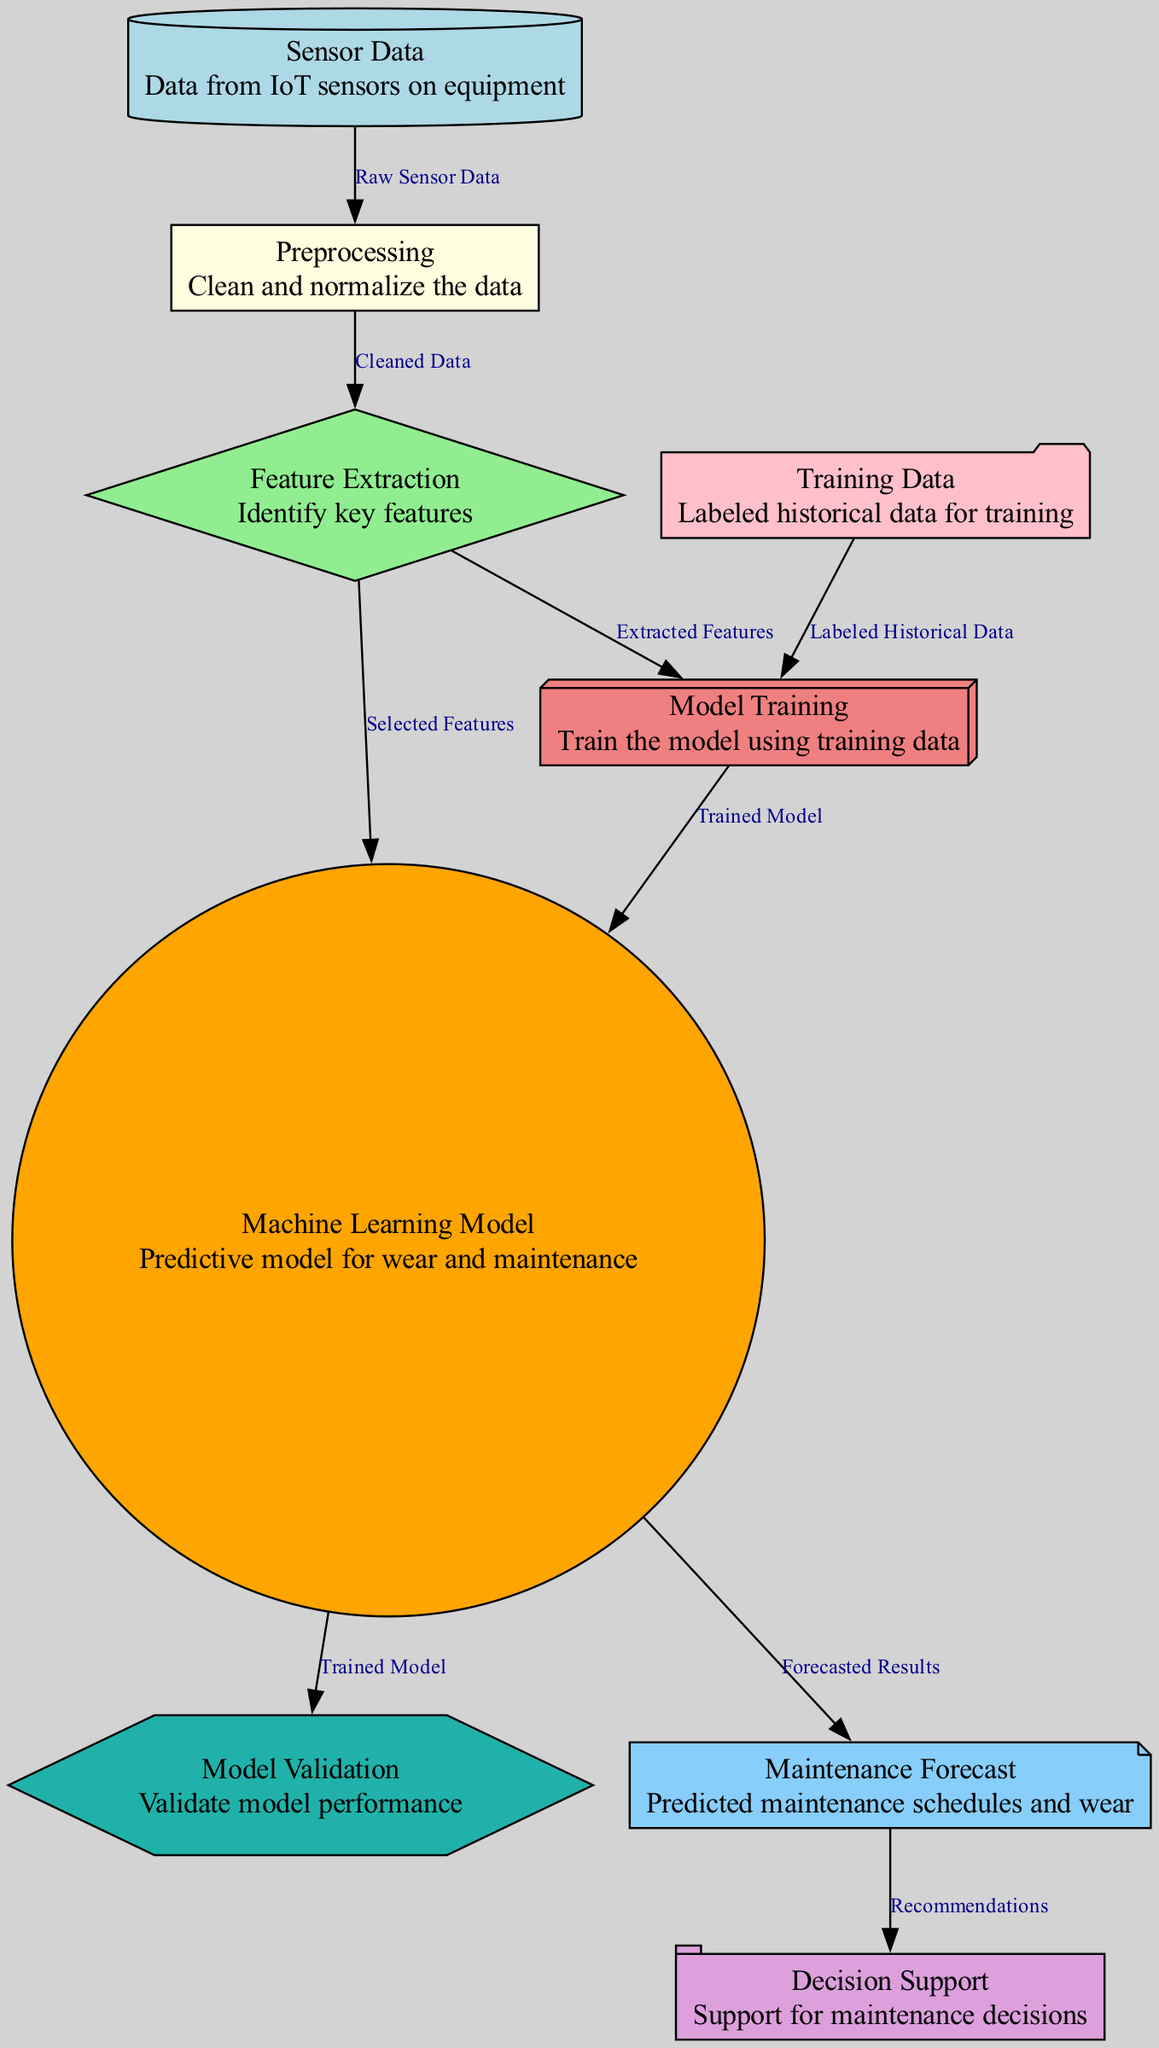What is the source of the data in the diagram? The source of the data in this diagram is indicated by the node labeled "Sensor Data," which represents data collected from IoT sensors on equipment.
Answer: Sensor Data How many nodes are present in the diagram? By counting all the listed nodes in the diagram, there are a total of nine nodes representing different stages in the process.
Answer: Nine What type of data is used in the "Model Training" step? The "Model Training" step is connected to the "Training Data" node, which refers to labeled historical data used to train the machine learning model.
Answer: Labeled Historical Data Which node connects to both "Feature Extraction" and "Model Training"? The node labeled "Feature Extraction" is connected to the "Machine Learning Model" and also provides extracted features to the "Model Training" node, indicating its role in preparing data for training the model.
Answer: Machine Learning Model What is the output of the "Maintenance Forecast" node? The "Maintenance Forecast" node outputs predicted maintenance schedules and wear, which leads to recommendations in the following "Decision Support" node.
Answer: Forecasted Results How do features reach the "Machine Learning Model"? Features are obtained from the "Feature Extraction" node and transferred directly to the "Machine Learning Model" for predictive modeling, as indicated by their connection in the diagram.
Answer: Selected Features Which process follows "Model Validation" in the diagram? After validating the model's performance in "Model Validation," the next step in the process is the "Maintenance Forecast," where predictions about maintenance schedules are made.
Answer: Maintenance Forecast What is the role of the "Decision Support" node? The "Decision Support" node provides recommendations based on the output from the "Maintenance Forecast" node, aiding in making informed maintenance decisions.
Answer: Recommendations 